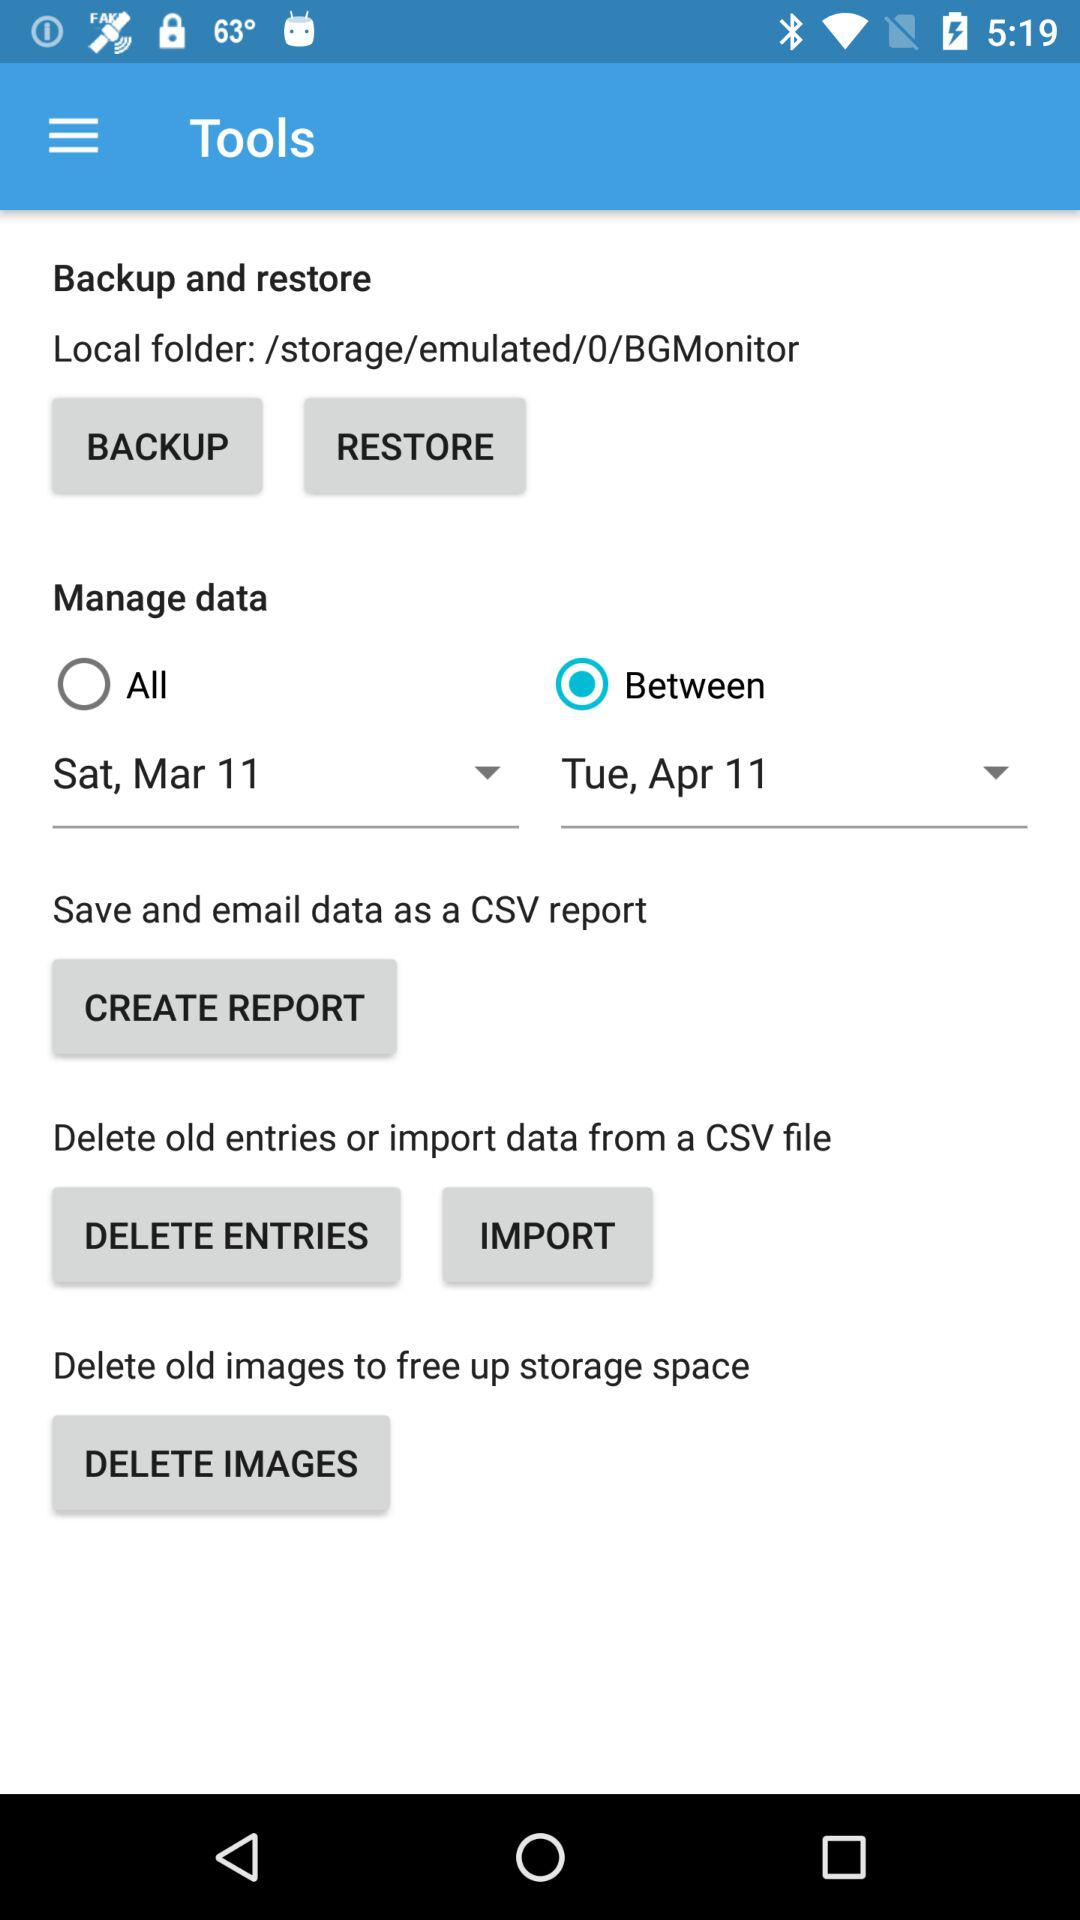From what file can the data be imported? The data can be imported from a CSV file. 